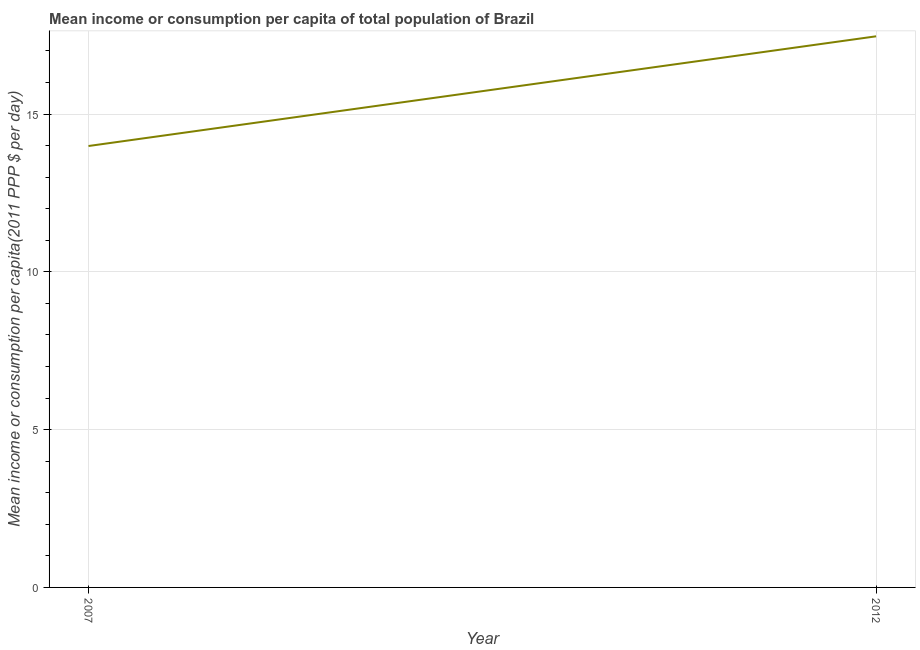What is the mean income or consumption in 2012?
Your answer should be very brief. 17.46. Across all years, what is the maximum mean income or consumption?
Offer a very short reply. 17.46. Across all years, what is the minimum mean income or consumption?
Your answer should be compact. 13.99. What is the sum of the mean income or consumption?
Offer a very short reply. 31.45. What is the difference between the mean income or consumption in 2007 and 2012?
Make the answer very short. -3.48. What is the average mean income or consumption per year?
Your answer should be very brief. 15.72. What is the median mean income or consumption?
Provide a short and direct response. 15.72. What is the ratio of the mean income or consumption in 2007 to that in 2012?
Your answer should be very brief. 0.8. In how many years, is the mean income or consumption greater than the average mean income or consumption taken over all years?
Make the answer very short. 1. Does the mean income or consumption monotonically increase over the years?
Ensure brevity in your answer.  Yes. How many years are there in the graph?
Your answer should be very brief. 2. Are the values on the major ticks of Y-axis written in scientific E-notation?
Provide a succinct answer. No. Does the graph contain grids?
Keep it short and to the point. Yes. What is the title of the graph?
Provide a short and direct response. Mean income or consumption per capita of total population of Brazil. What is the label or title of the Y-axis?
Your answer should be compact. Mean income or consumption per capita(2011 PPP $ per day). What is the Mean income or consumption per capita(2011 PPP $ per day) in 2007?
Keep it short and to the point. 13.99. What is the Mean income or consumption per capita(2011 PPP $ per day) in 2012?
Offer a terse response. 17.46. What is the difference between the Mean income or consumption per capita(2011 PPP $ per day) in 2007 and 2012?
Offer a terse response. -3.48. What is the ratio of the Mean income or consumption per capita(2011 PPP $ per day) in 2007 to that in 2012?
Your answer should be compact. 0.8. 